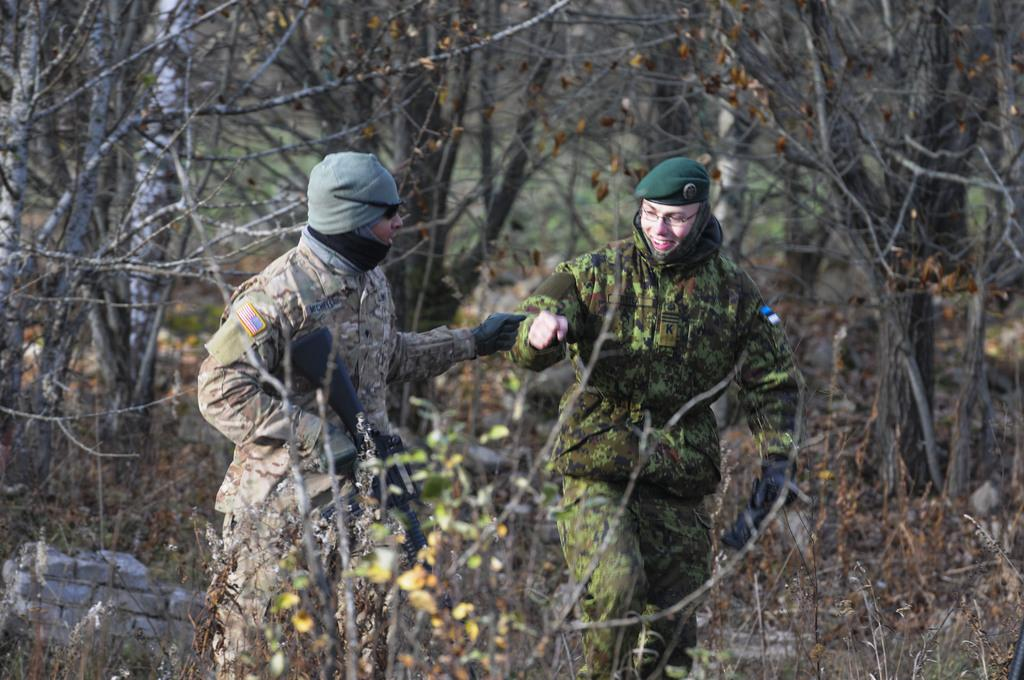How many people are in the image? There are two persons in the image. What are the persons holding in the image? The persons are holding guns. What can be seen in the background of the image? There are trees in the background of the image. What type of swing can be seen in the image? There is no swing present in the image. How many toes can be seen on the persons in the image? The image does not show the toes of the persons, so it cannot be determined from the image. 